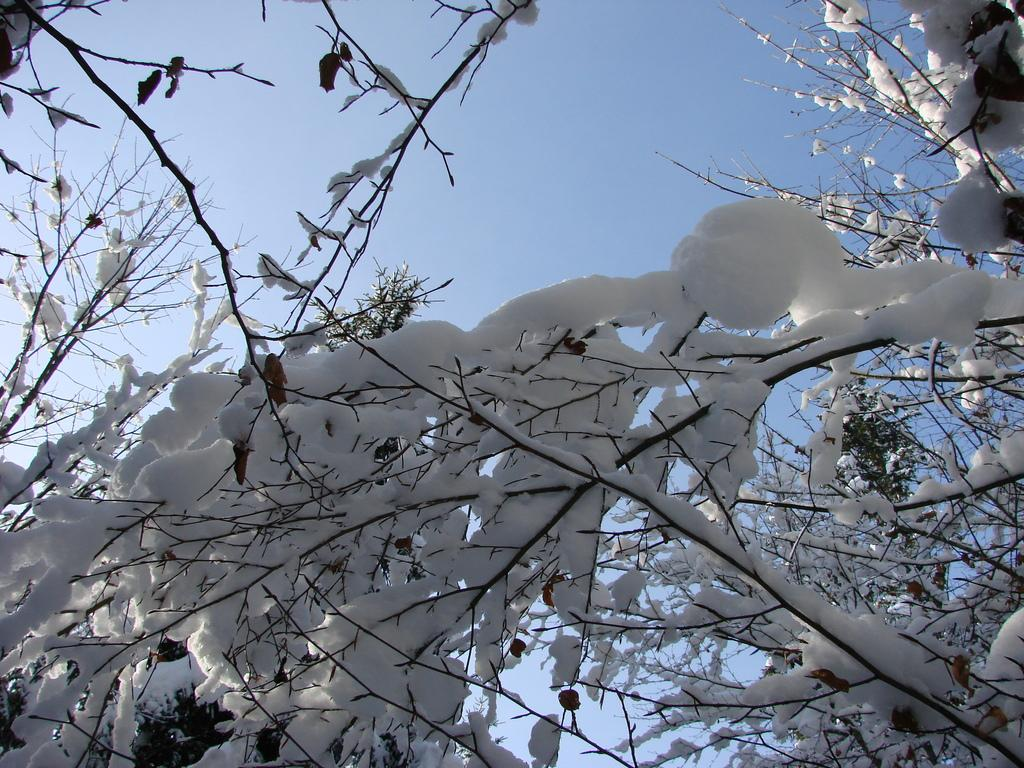Where was the picture taken? The picture was clicked outside. What is covering the stems of the tree in the foreground? There is snow on the stems of the tree in the foreground. What can be seen in the background of the image? The sky is visible in the background. What type of agreement is being signed in the image? There is no agreement or any indication of a signing event in the image; it features a tree with snow on its stems and a visible sky in the background. 